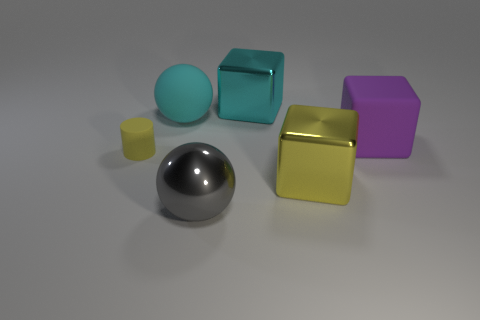Add 3 yellow metallic things. How many objects exist? 9 Subtract all balls. How many objects are left? 4 Add 2 shiny spheres. How many shiny spheres exist? 3 Subtract 1 yellow cylinders. How many objects are left? 5 Subtract all small rubber balls. Subtract all big rubber balls. How many objects are left? 5 Add 1 large cyan blocks. How many large cyan blocks are left? 2 